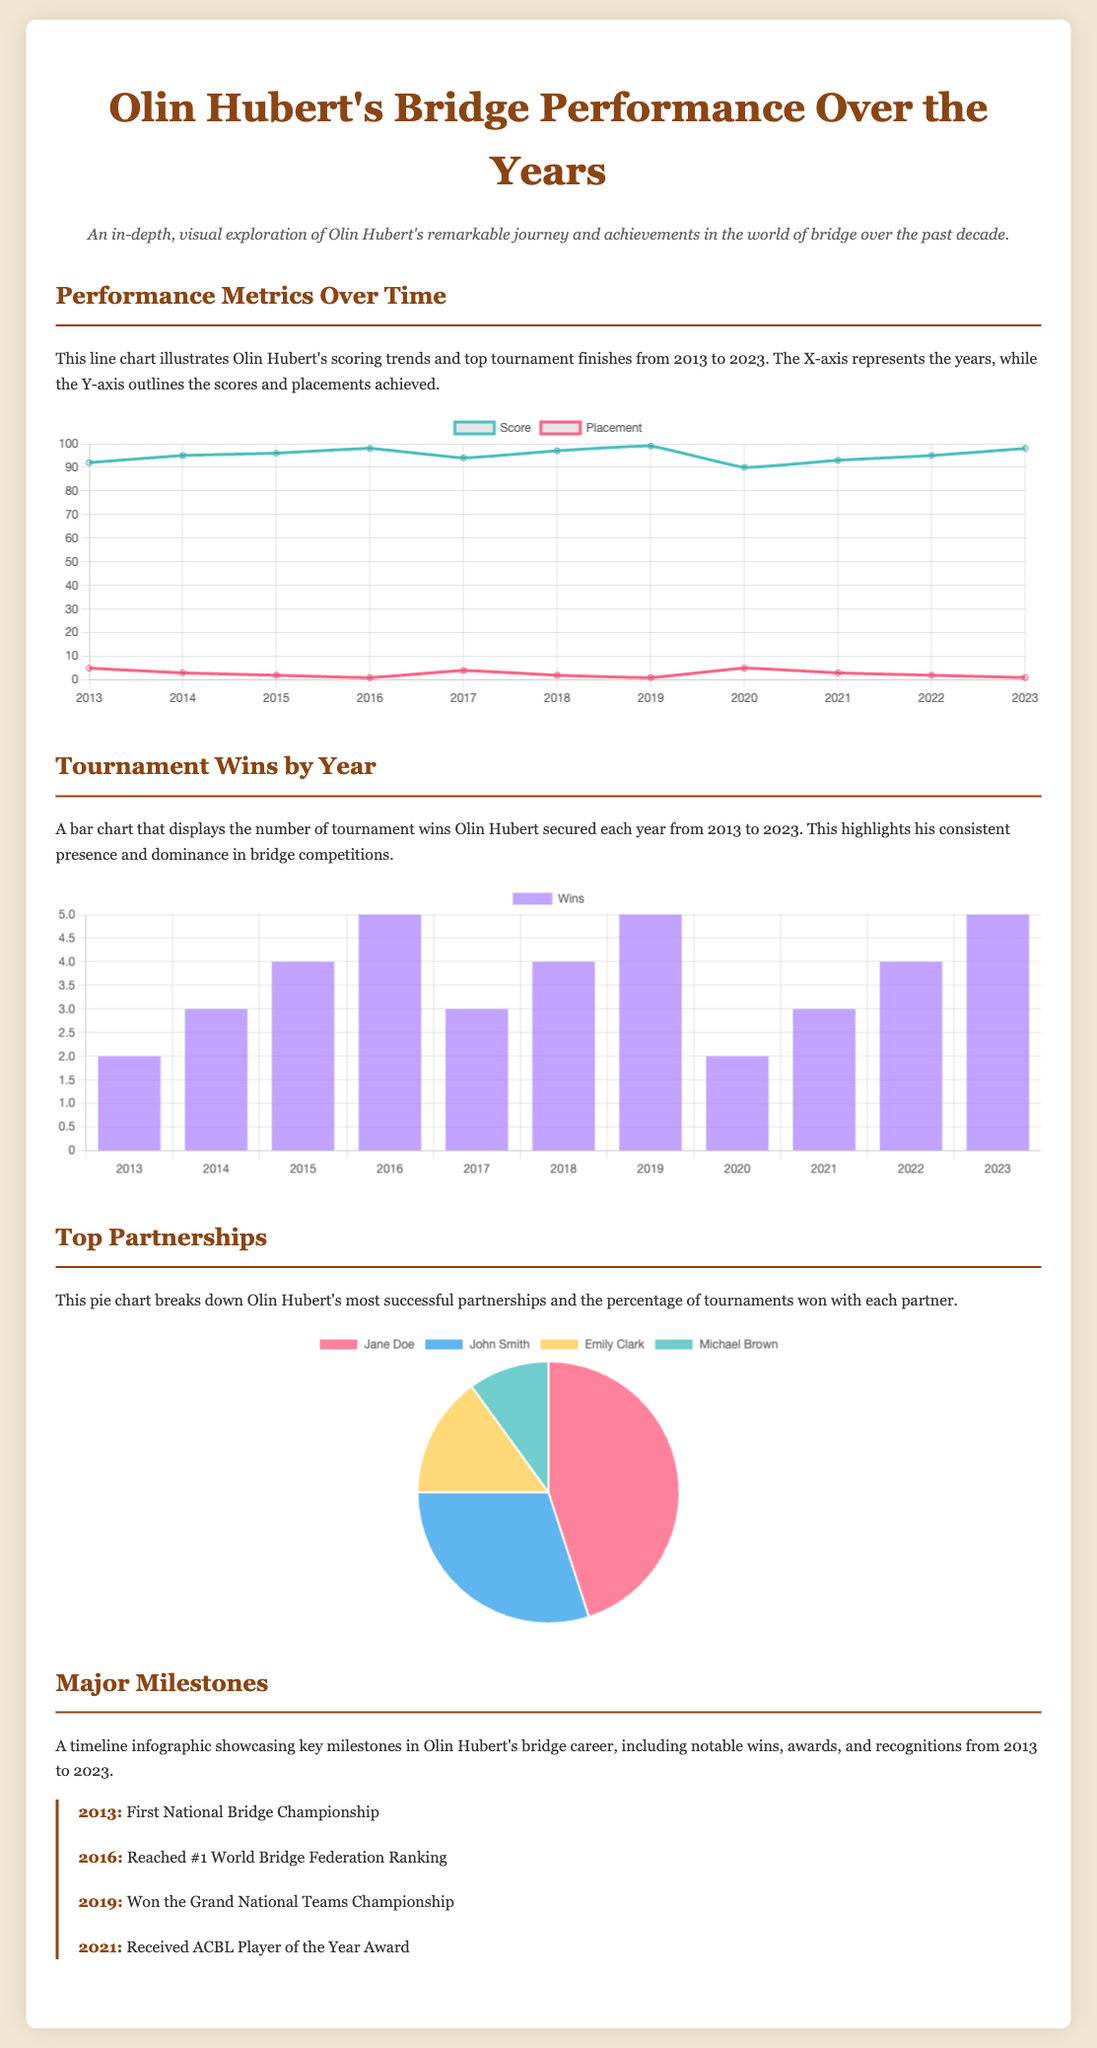What year did Olin Hubert win the Grand National Teams Championship? This can be found in the Major Milestones section, which lists key achievements by year.
Answer: 2019 How many tournament wins did Olin Hubert achieve in 2021? The Tournament Wins by Year bar chart shows the total number of wins for each year.
Answer: 3 What was Olin Hubert's score in 2016? The Performance Metrics Over Time line chart illustrates the scores achieved by year.
Answer: 98 Which partner had the highest percentage of tournament wins with Olin Hubert? The Top Partnerships pie chart presents the breakdown of successful partnerships by percentage.
Answer: Jane Doe What was Olin Hubert's world ranking in 2016? This information is noted in the Major Milestones section, highlighting milestones in his bridge career.
Answer: #1 World Bridge Federation Ranking How many years did Olin Hubert achieve a score of 95 or higher? By analyzing the Performance Metrics Over Time line chart, we can count the years with scores of 95 and above.
Answer: 6 